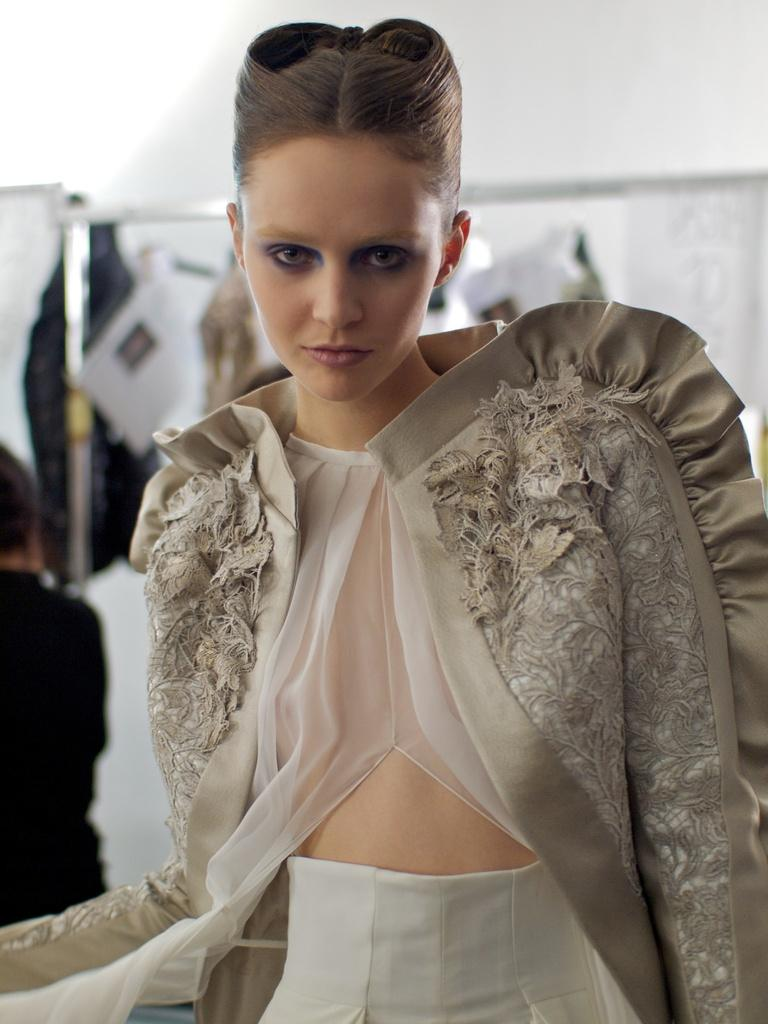What is the main subject of the image? There is a woman standing in the image. How would you describe the background of the image? The background of the image is blurry. Can you see any other people in the image? Yes, there is a person visible in the background of the image. What else can be seen in the background of the image? There are objects present in the background of the image. What type of bait is being used by the woman in the image? There is no bait present in the image, as it features a woman standing with a blurry background. 